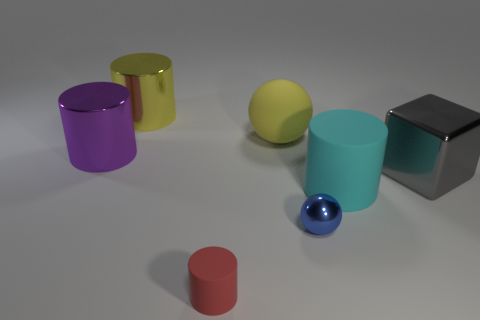Subtract all red rubber cylinders. How many cylinders are left? 3 Subtract all yellow cylinders. How many cylinders are left? 3 Add 1 big green things. How many objects exist? 8 Subtract all spheres. How many objects are left? 5 Add 1 large purple metal cylinders. How many large purple metal cylinders are left? 2 Add 1 large green rubber cylinders. How many large green rubber cylinders exist? 1 Subtract 1 yellow balls. How many objects are left? 6 Subtract 2 spheres. How many spheres are left? 0 Subtract all purple spheres. Subtract all green cylinders. How many spheres are left? 2 Subtract all purple spheres. How many brown blocks are left? 0 